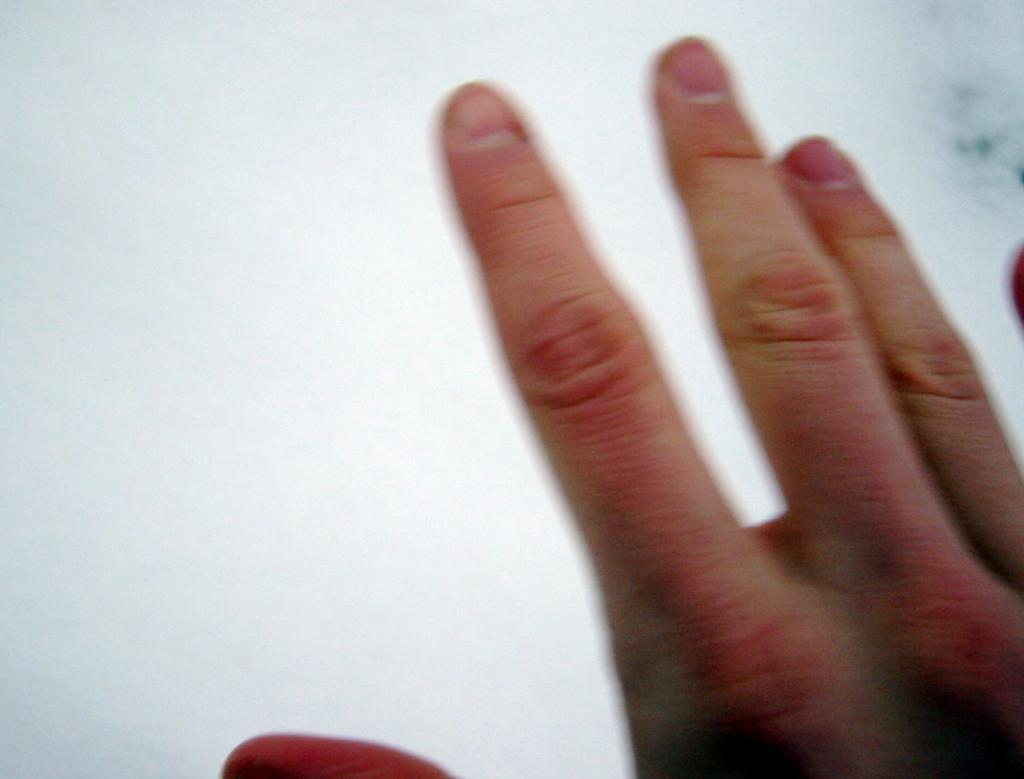What can be seen in the image? There is a person's hand in the image. What is the color of the background behind the hand? The background behind the hand is white. How many houses can be seen in the image? There are no houses present in the image; it only features a person's hand and a white background. What type of frogs can be seen in the image? There are no frogs present in the image. 